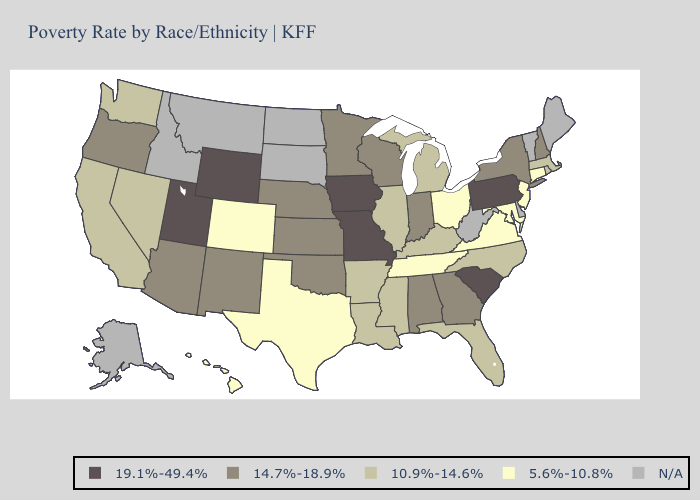Does Kentucky have the lowest value in the South?
Short answer required. No. Name the states that have a value in the range 10.9%-14.6%?
Quick response, please. Arkansas, California, Florida, Illinois, Kentucky, Louisiana, Massachusetts, Michigan, Mississippi, Nevada, North Carolina, Rhode Island, Washington. What is the value of Wisconsin?
Write a very short answer. 14.7%-18.9%. Among the states that border Arkansas , does Mississippi have the highest value?
Short answer required. No. What is the value of Alaska?
Be succinct. N/A. What is the lowest value in the USA?
Give a very brief answer. 5.6%-10.8%. What is the highest value in the USA?
Keep it brief. 19.1%-49.4%. Which states hav the highest value in the South?
Give a very brief answer. South Carolina. What is the value of Wyoming?
Be succinct. 19.1%-49.4%. What is the value of Minnesota?
Write a very short answer. 14.7%-18.9%. What is the value of North Carolina?
Write a very short answer. 10.9%-14.6%. What is the value of Hawaii?
Write a very short answer. 5.6%-10.8%. Does the first symbol in the legend represent the smallest category?
Quick response, please. No. What is the highest value in states that border Florida?
Concise answer only. 14.7%-18.9%. Name the states that have a value in the range 19.1%-49.4%?
Give a very brief answer. Iowa, Missouri, Pennsylvania, South Carolina, Utah, Wyoming. 